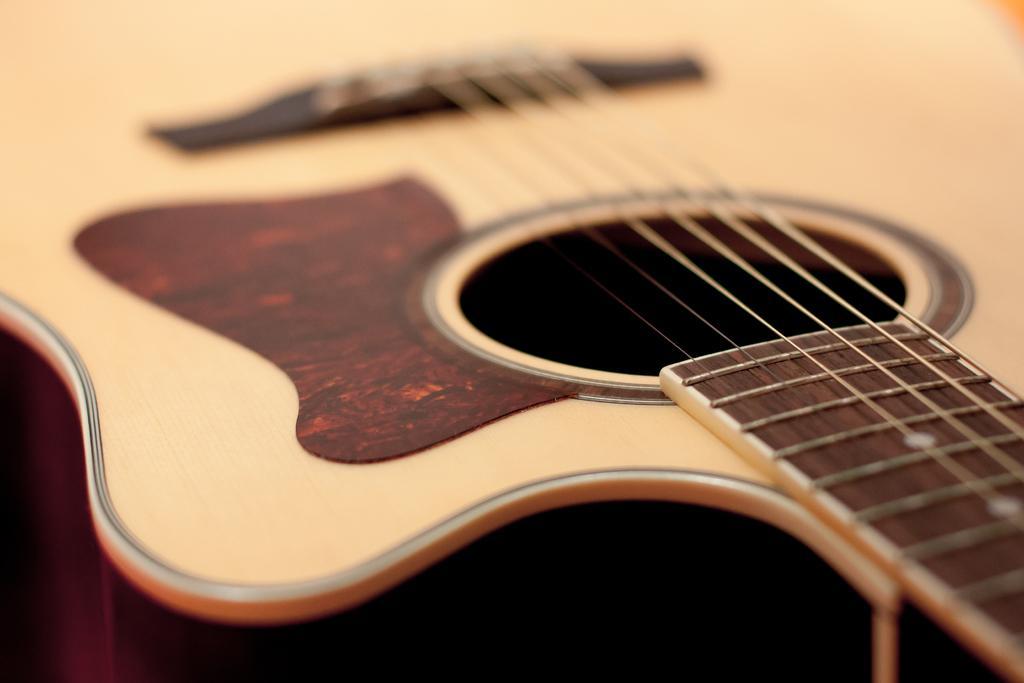Could you give a brief overview of what you see in this image? In the image there is a wooden color beautiful guitar. 